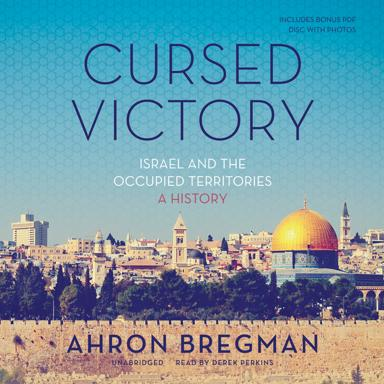What format is the book mentioned in the image available in? The book "Cursed Victory: Israel and the Occupied Territories: A History" is available in an unabridged audiobook format, narrated by Derek Perkins, enhancing the auditory learning experience. 